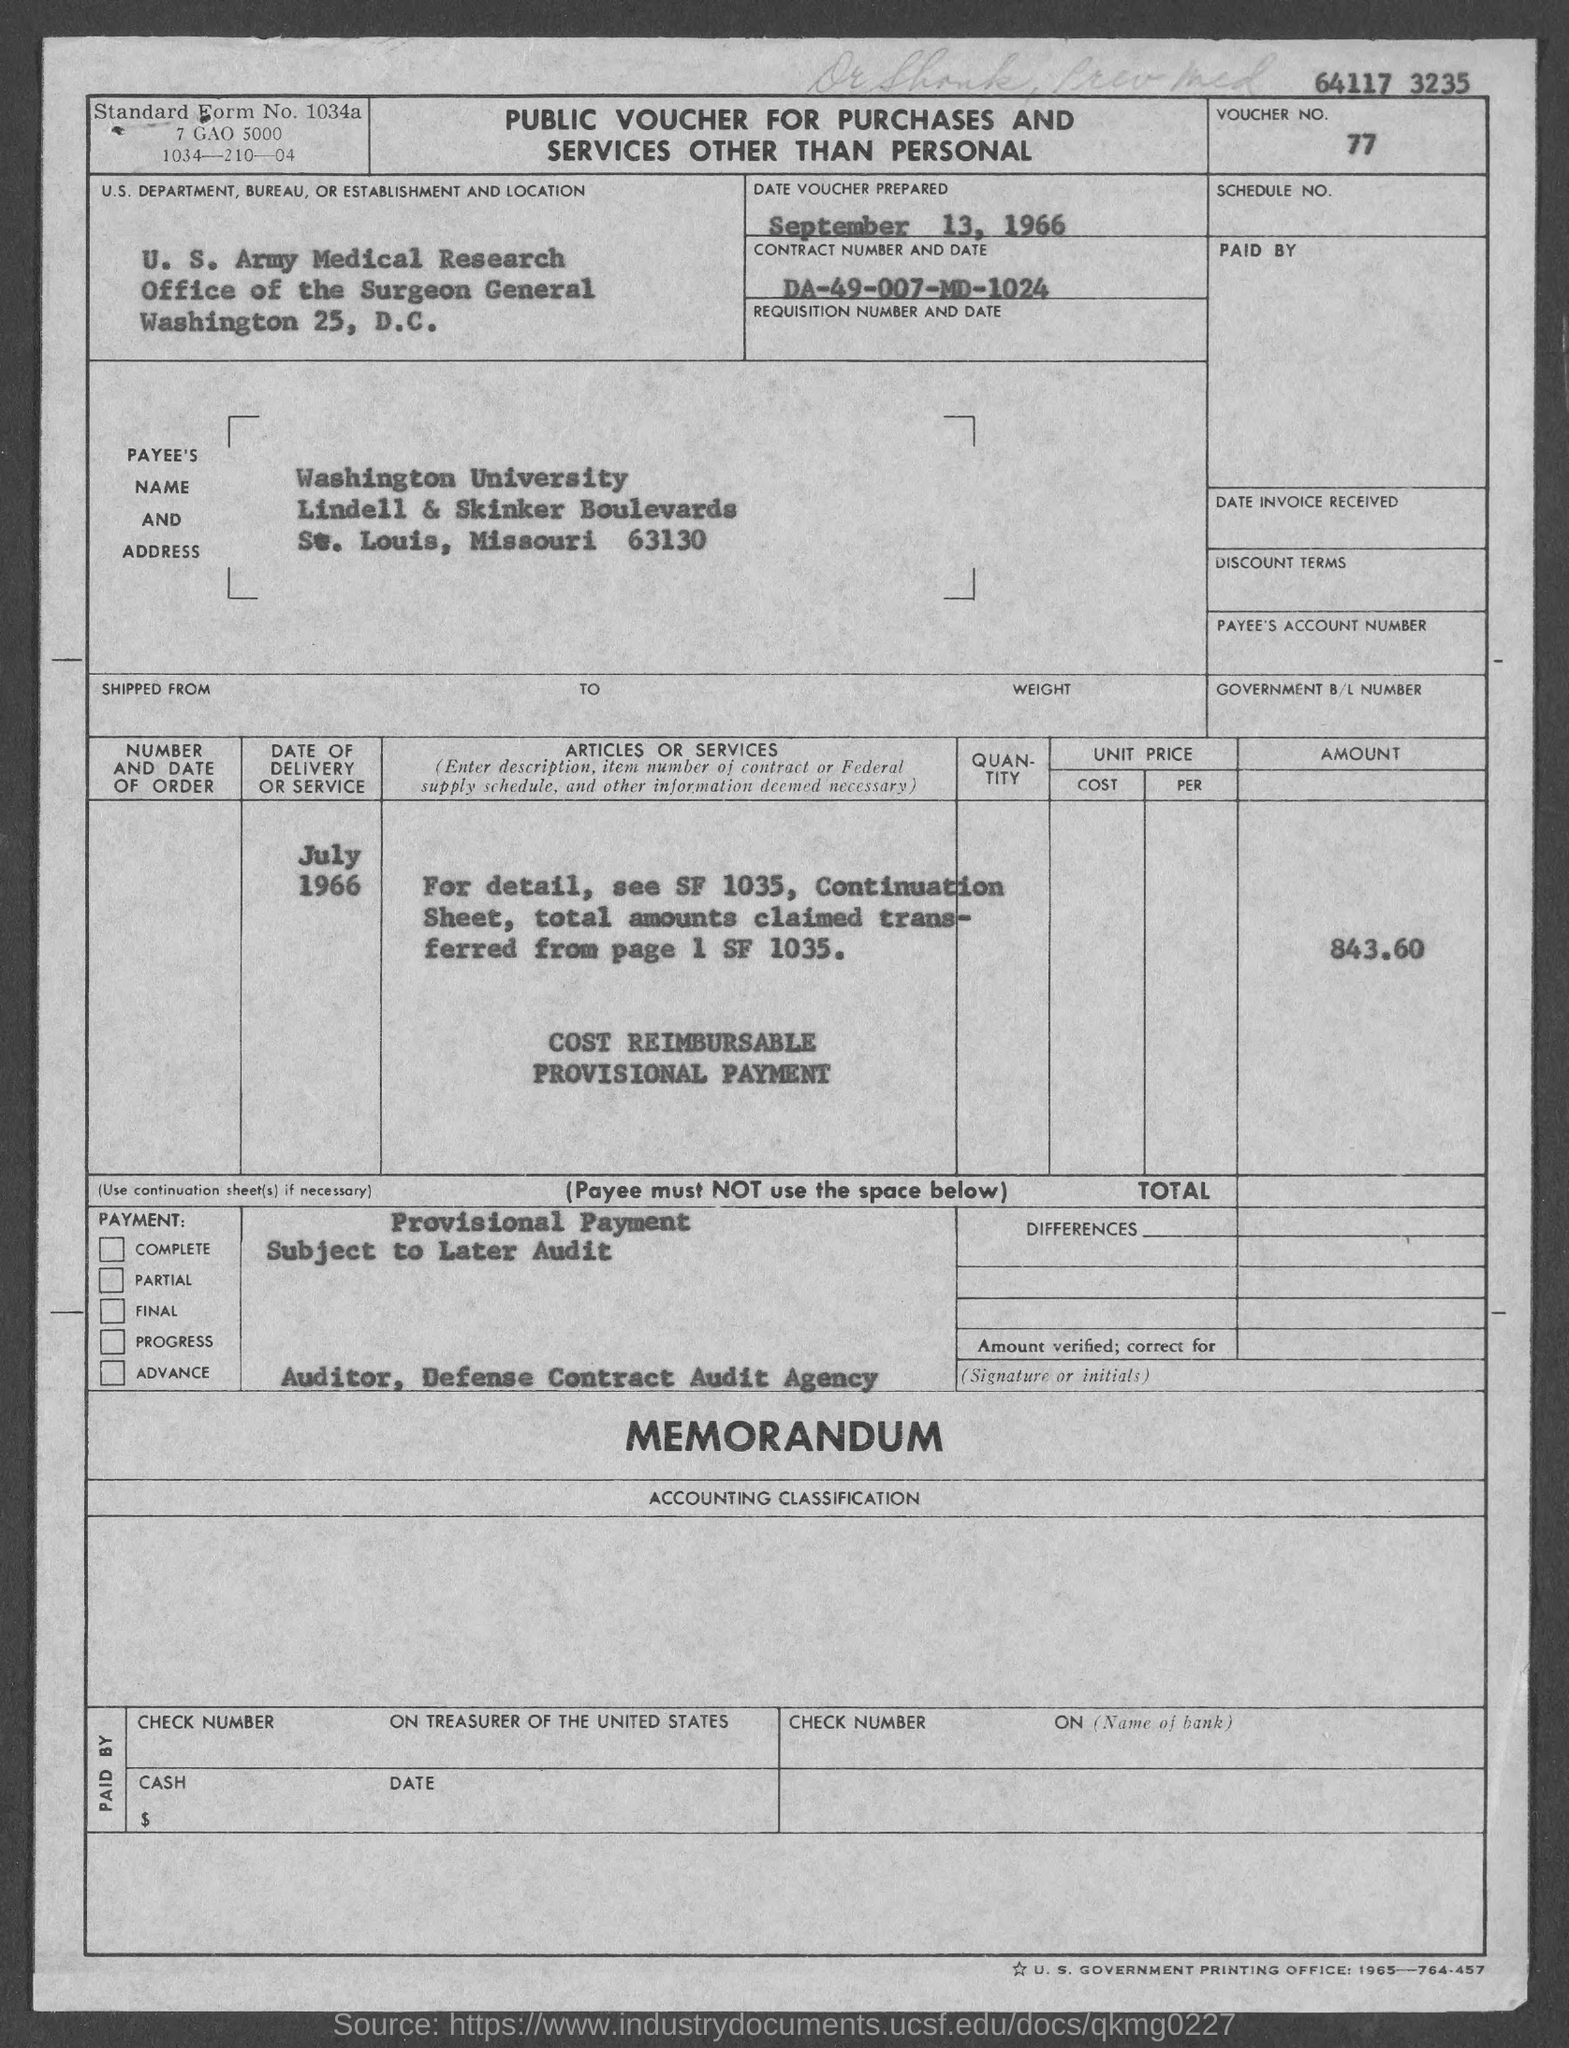What is the voucher no.?
Ensure brevity in your answer.  77. What is the contract number ?
Offer a very short reply. DA-49-007-MD-1024. What is the standard form no.?
Provide a short and direct response. 1034a. On what date is voucher prepared ?
Your answer should be very brief. September 13, 1966. 